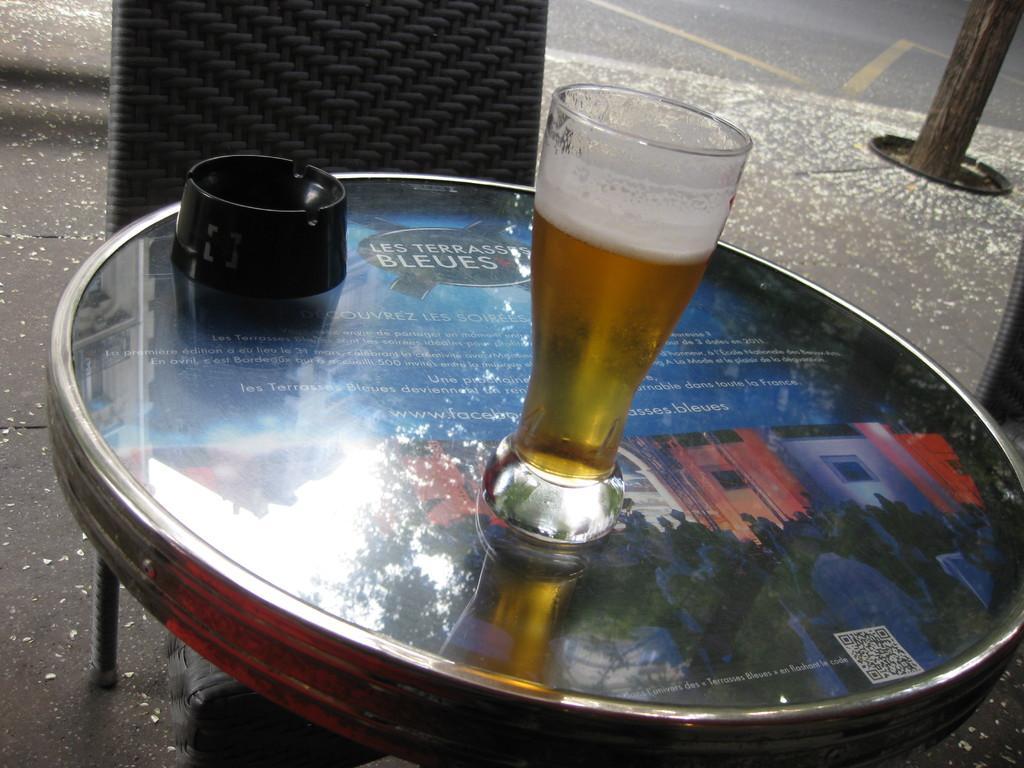Describe this image in one or two sentences. In this image I can see a table , on the table I can see a drink contain a glass and in front of table I can see a chair and a stand visible kept on table on the right side. 